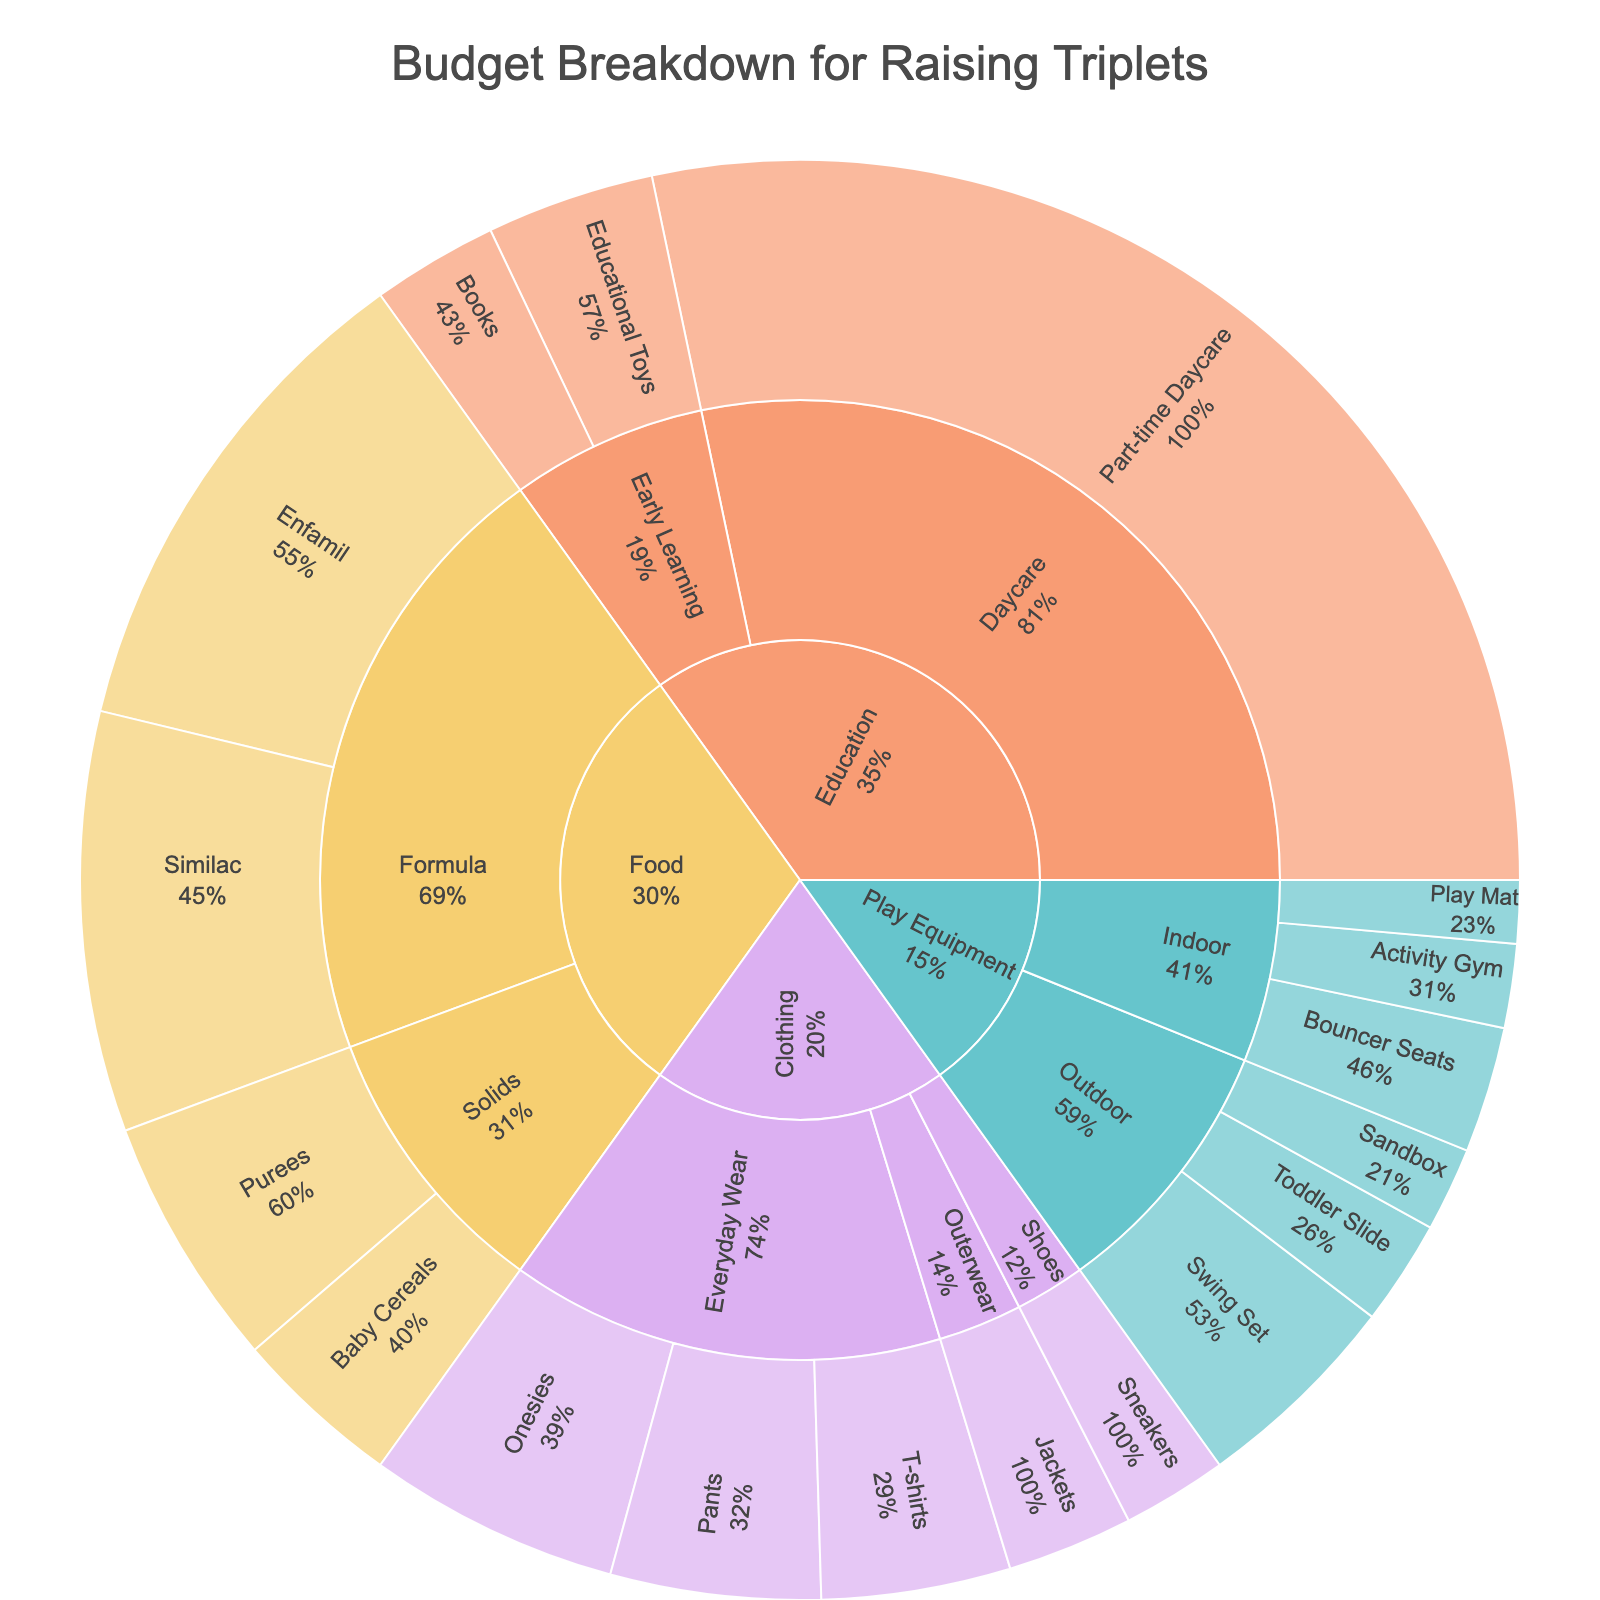What is the title of the Sunburst Plot? The title is typically at the top of the chart. It describes the purpose of the plot.
Answer: Budget Breakdown for Raising Triplets Which category has the highest overall budget? Identify the size of each main segment in the Sunburst Plot. The one with the largest segment has the highest budget.
Answer: Food What is the total budget for the subcategory 'Everyday Wear'? Sum up the values for items under 'Everyday Wear' (Onesies, T-shirts, Pants). 600 + 450 + 500 = 1550
Answer: $1550 How does the budget for 'Education' compare to 'Play Equipment'? Find the total values for each category and compare. Education: Books(300) + Educational Toys(400) + Daycare(3000) = 3700. Play Equipment: Play Mat(150) + Activity Gym(200) + Bouncer Seats(300) + Toddler Slide(250) + Sandbox(200) + Swing Set(500) = 1600
Answer: Education is $2100 higher Which subcategory has the smallest budget in the 'Clothing' category? Look at the sizes of subcategories within 'Clothing'. The smallest one is 'Shoes'.
Answer: Shoes How much more is spent on 'Formula' compared to 'Solids' within the 'Food' category? Subtract the total of 'Solids' from the total of 'Formula'. Formula: Enfamil(1200) + Similac(1000) = 2200. Solids: Baby Cereals(400) + Purees(600) = 1000. 2200 - 1000 = 1200
Answer: $1200 What is the total amount spent on 'Play Equipment'? Sum the values of all items under 'Play Equipment'. Play Mat(150) + Activity Gym(200) + Bouncer Seats(300) + Toddler Slide(250) + Sandbox(200) + Swing Set(500) = 1600
Answer: $1600 Which item in the 'Education' category has the highest budget? Compare the sizes of items under 'Education'. 'Part-time Daycare' has the highest value.
Answer: Part-time Daycare What's the average budget for individual items within 'Food'? Sum the values for all 'Food' items, then divide by the number of items. Total for Food is 2200 + 1000 = 3200. There are 4 items. 3200 / 4 = 800
Answer: $800 